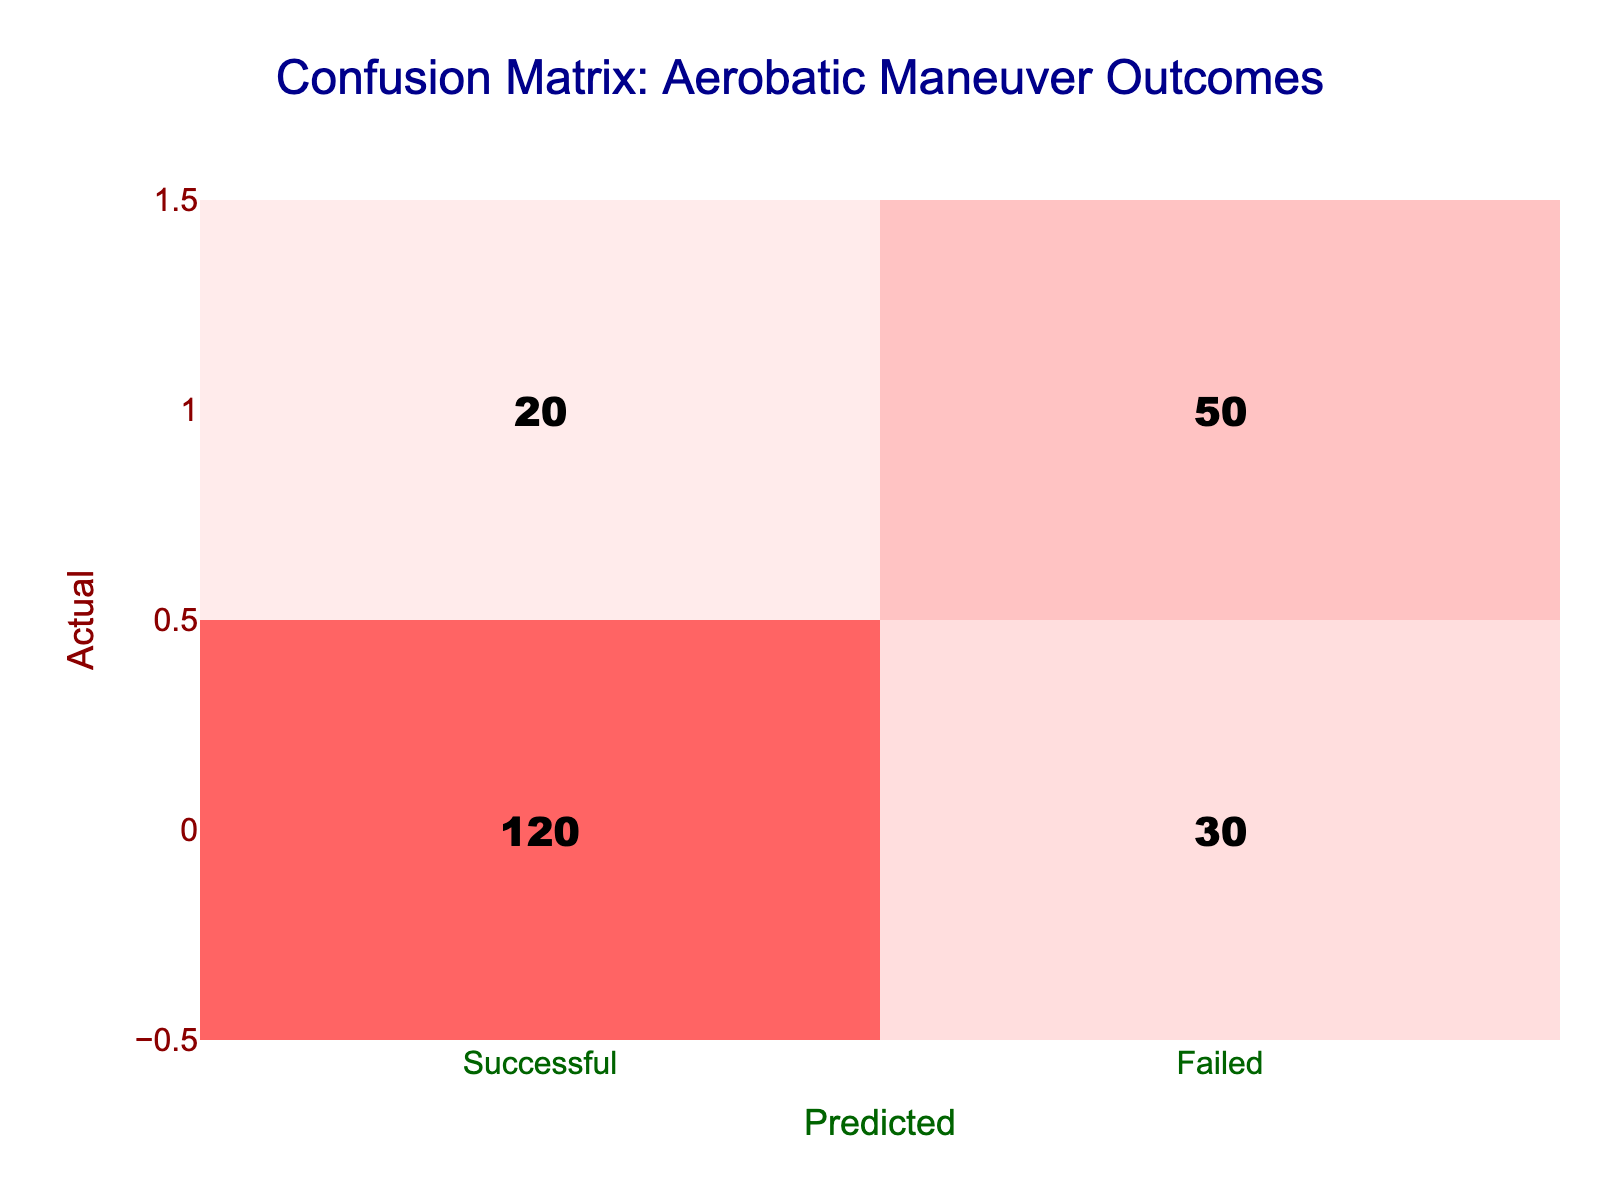What is the total number of successful outcomes predicted? From the table, the predicted successful outcomes are the values in the "Successful" column. Adding these values gives us 120 (True Positive) + 30 (False Negative) = 150.
Answer: 150 How many pilots actually failed but were predicted to be successful? The value for "Failed" actual outcomes that were predicted as "Successful" is 30, which represents the False Negative.
Answer: 30 What is the ratio of successful predictions to failed predictions? The total successful predictions are 120 + 30 = 150, and the total failed predictions are 20 + 50 = 70. The ratio is therefore calculated as 150:70, which simplifies to approximately 15:7.
Answer: 15:7 Was the number of successful outcomes greater than the number of failed outcomes? The total successful outcomes are 120 + 30 = 150, and the total failed outcomes are 20 + 50 = 70. Comparing these numbers, 150 is greater than 70, thus the statement is true.
Answer: Yes What is the accuracy of the predictions? Accuracy is calculated as (True Positives + True Negatives) / Total Predictions. True Positives are 120, True Negatives are 50, giving us a total of 170 correct predictions out of 220 total predictions (120 + 30 + 20 + 50). Therefore, accuracy is 170/220 = 0.7727 or 77.27%.
Answer: 77.27% How many more successful outcomes were predicted than failed outcomes? The total predicted successful outcomes are 150, and the total predicted failed outcomes are 70. The difference is 150 - 70 = 80.
Answer: 80 Is the failure rate among pilots higher than the success rate? The failure rate is calculated as the number of actual failures (20 + 50) / Total pilots (220), and the success rate is the number of actual successes (120 + 30) / Total pilots (220). The failure rate is 70/220 = 0.318 and the success rate is 150/220 = 0.682. Thus, the failure rate is lower than the success rate.
Answer: No What steps would you take to improve the prediction outcomes based on this matrix? To improve prediction outcomes, increasing training quality could enhance the training techniques and post-flight analyses. Evaluating maneuver success in simulation environments might also help, as would reviewing the failed cases to identify patterns contributing to failures. Exploring additional data and pilot characteristics could refine predictive modeling.
Answer: Multiple steps needed 